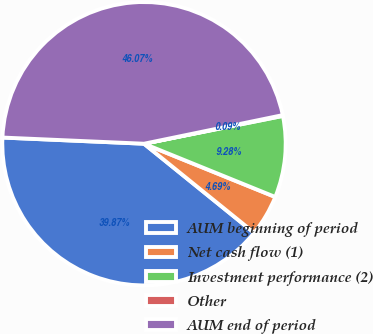Convert chart. <chart><loc_0><loc_0><loc_500><loc_500><pie_chart><fcel>AUM beginning of period<fcel>Net cash flow (1)<fcel>Investment performance (2)<fcel>Other<fcel>AUM end of period<nl><fcel>39.87%<fcel>4.69%<fcel>9.28%<fcel>0.09%<fcel>46.07%<nl></chart> 